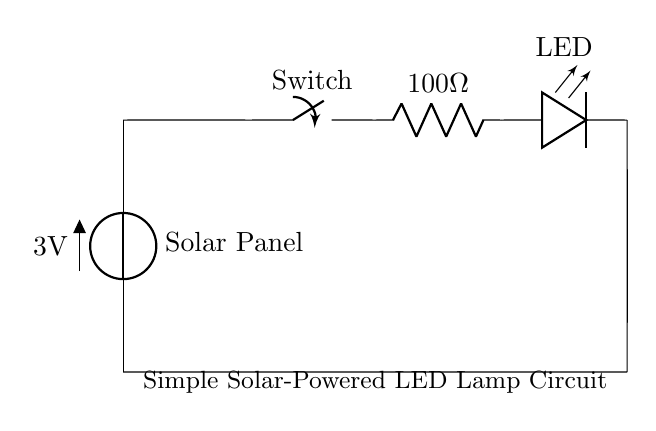What is the voltage of the solar panel? The voltage of the solar panel is indicated as 3V in the circuit diagram. This is the voltage source connected to the circuit's components.
Answer: 3V What is the value of the resistor in the circuit? The resistor in the circuit is labeled as 100 ohms, which is a standard value that helps to limit the current flowing through the LED.
Answer: 100 ohms What type of switch is used in this circuit? The switch in this circuit is a standard switch, which can control the flow of electricity when toggled on or off, thereby controlling the operation of the LED.
Answer: Switch How many components are in this circuit? If we count the components shown - the solar panel, switch, resistor, and LED - there are four distinct components in the circuit.
Answer: 4 What will happen if the switch is open? If the switch is open, there will be no electrical connection between the solar panel and the LED, resulting in the LED not lighting up, as the circuit would be incomplete.
Answer: LED will not light up Which component provides power to the LED? The solar panel provides the power to the LED by acting as the voltage source for the entire circuit, allowing current to flow when the switch is closed.
Answer: Solar panel What is the purpose of the resistor in this circuit? The purpose of the resistor is to limit the amount of current flowing through the LED, thereby preventing it from receiving too much current and getting damaged.
Answer: Limit current 